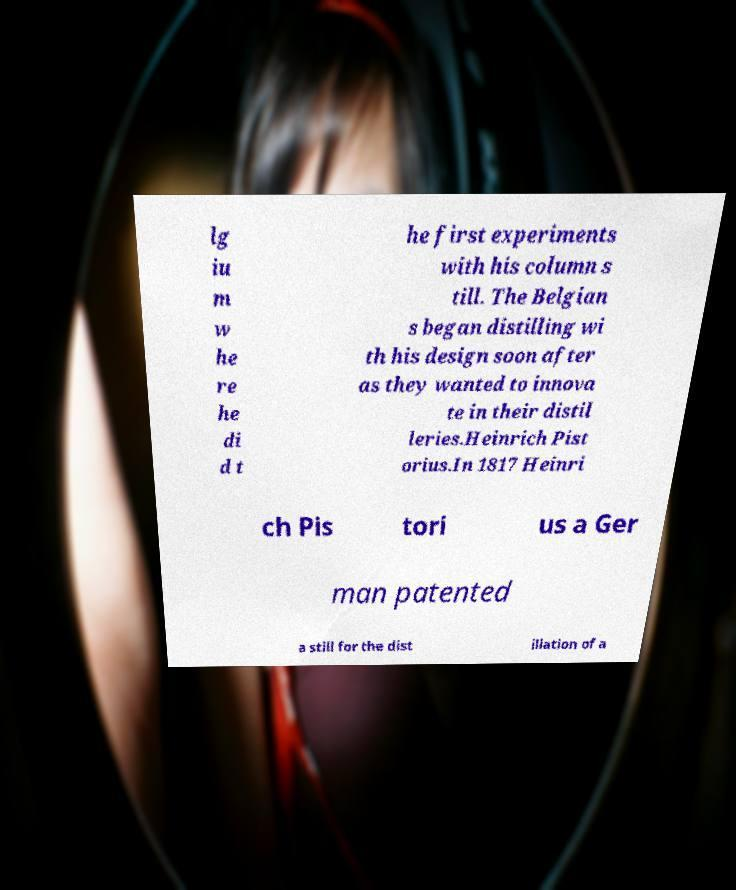Please read and relay the text visible in this image. What does it say? lg iu m w he re he di d t he first experiments with his column s till. The Belgian s began distilling wi th his design soon after as they wanted to innova te in their distil leries.Heinrich Pist orius.In 1817 Heinri ch Pis tori us a Ger man patented a still for the dist illation of a 